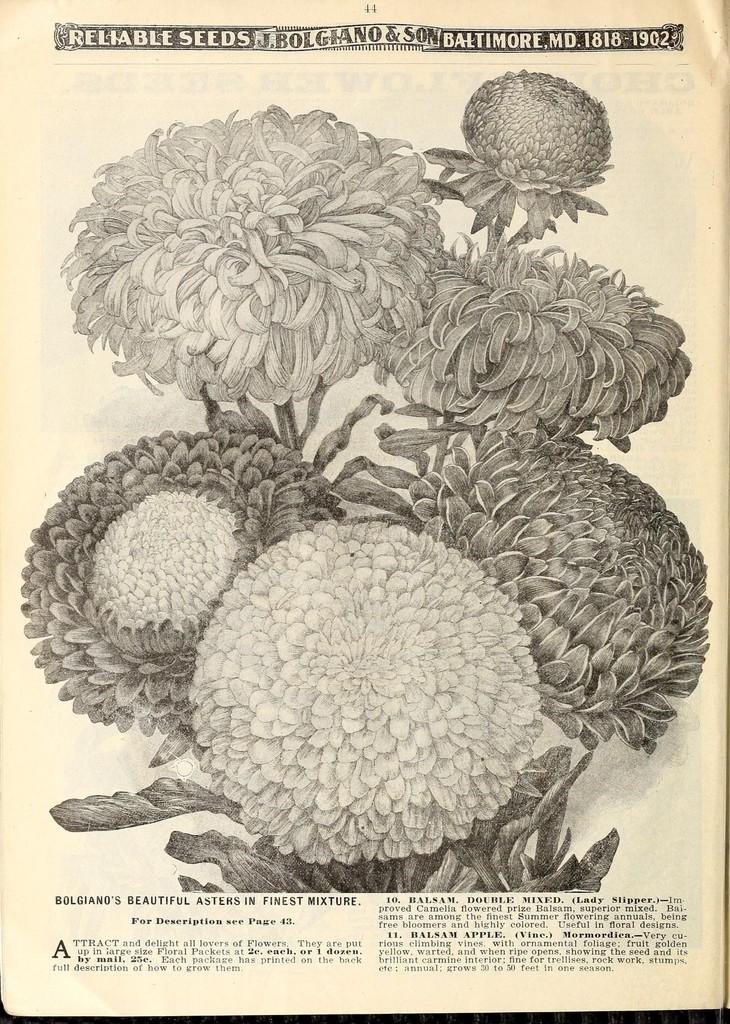Could you give a brief overview of what you see in this image? In the picture there is a paper, on the paper there are diagrams of flowers and there is some text present. 